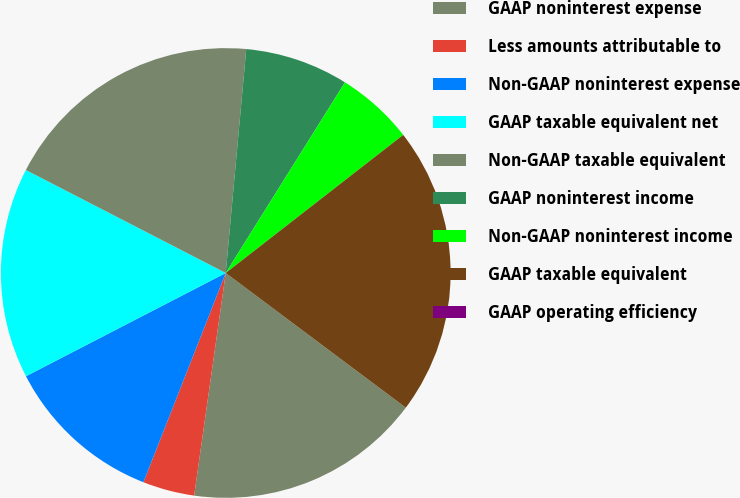Convert chart. <chart><loc_0><loc_0><loc_500><loc_500><pie_chart><fcel>GAAP noninterest expense<fcel>Less amounts attributable to<fcel>Non-GAAP noninterest expense<fcel>GAAP taxable equivalent net<fcel>Non-GAAP taxable equivalent<fcel>GAAP noninterest income<fcel>Non-GAAP noninterest income<fcel>GAAP taxable equivalent<fcel>GAAP operating efficiency<nl><fcel>17.02%<fcel>3.72%<fcel>11.44%<fcel>15.16%<fcel>18.88%<fcel>7.44%<fcel>5.58%<fcel>20.74%<fcel>0.0%<nl></chart> 